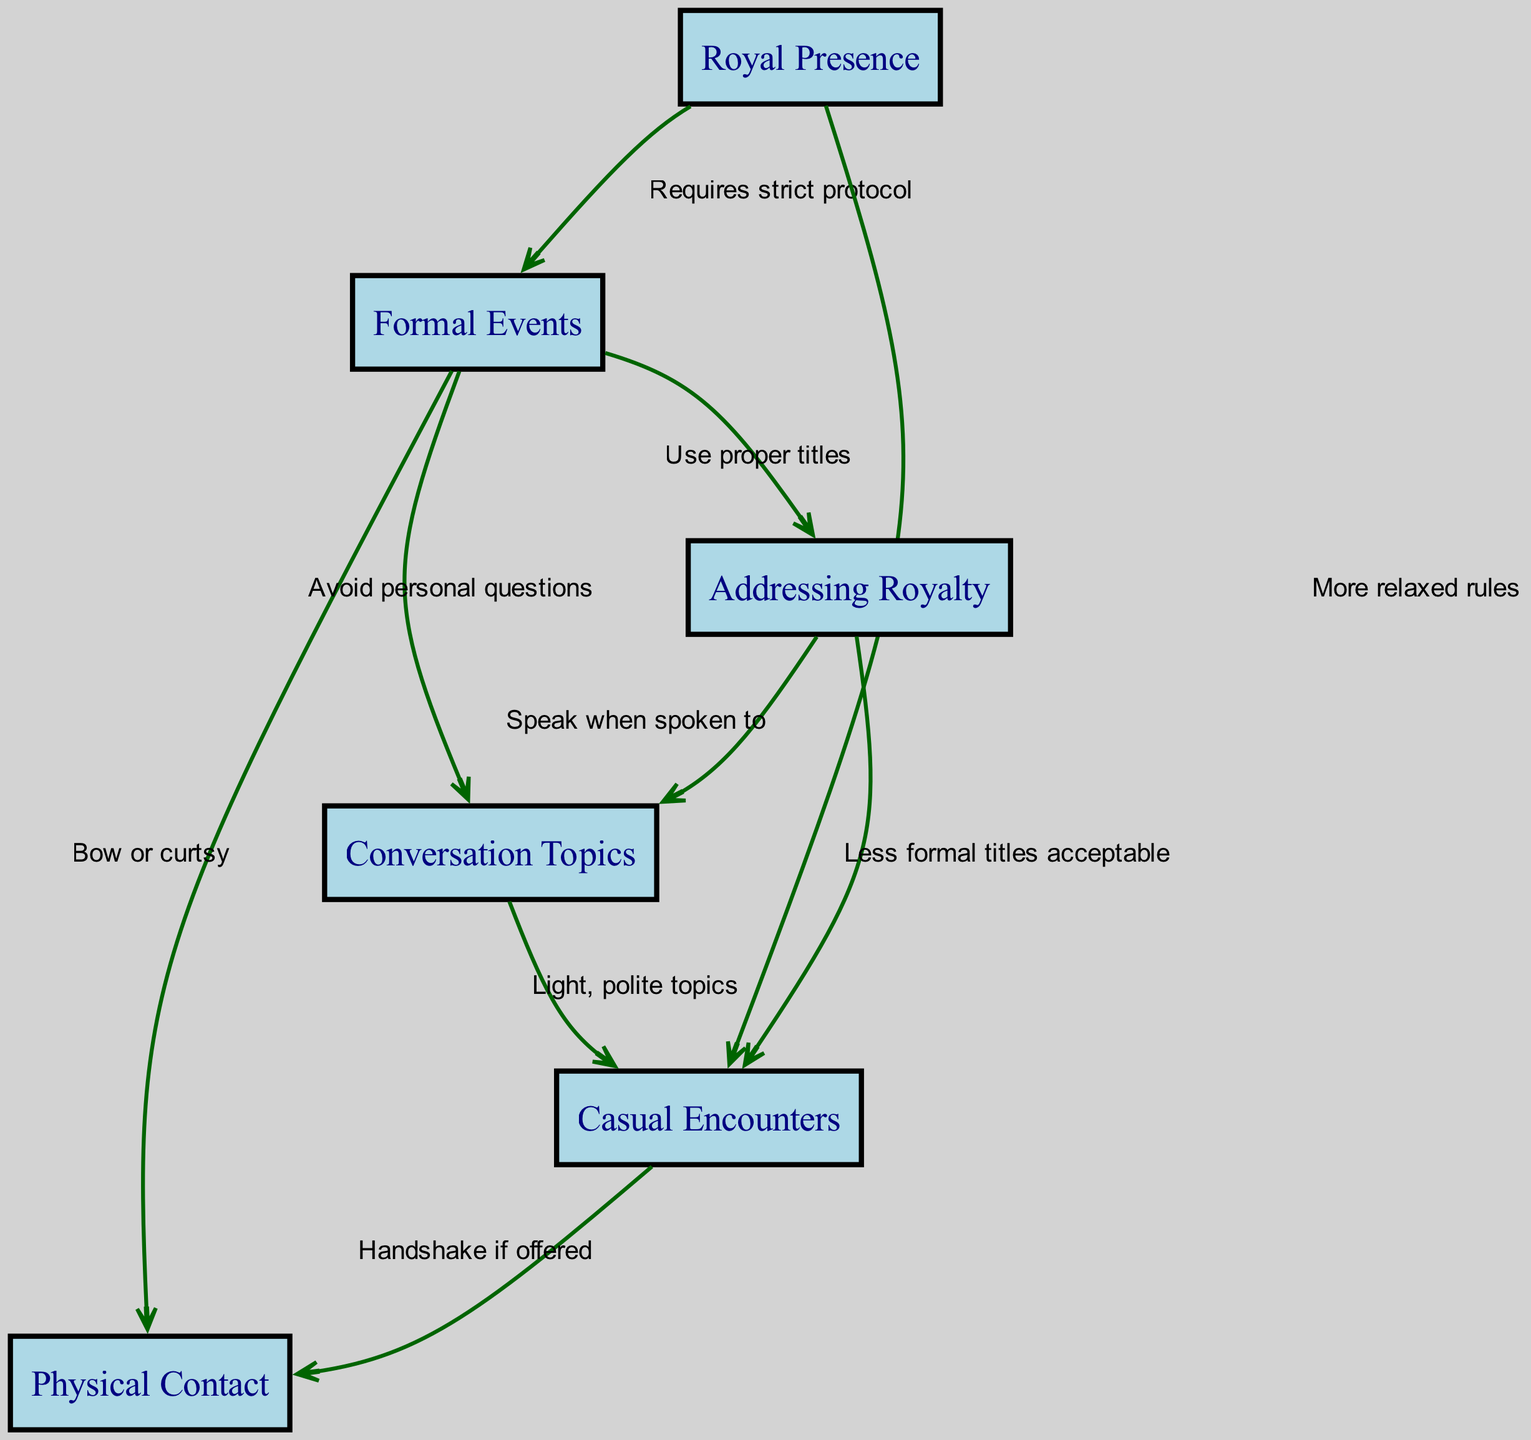What are the types of events depicted in the diagram? The diagram shows two types of events: Formal Events and Casual Encounters. These are identified as distinct nodes in the directed graph.
Answer: Formal Events, Casual Encounters How many nodes are there in the diagram? By counting the distinct nodes listed in the diagram data, we find there are a total of six nodes.
Answer: 6 What relationship exists between Formal Events and Addressing Royalty? The edge connecting Formal Events to Addressing Royalty indicates that during Formal Events, one must use proper titles when addressing royalty.
Answer: Use proper titles What is required for Royal Presence during Formal Events? The directed edge from Royal Presence to Formal Events states that Formal Events require strict protocol when interacting with royalty.
Answer: Requires strict protocol What should you discuss when speaking with royalty at Formal Events? The edge moving from Addressing Royalty to Conversation Topics shows that one should speak only when spoken to at Formal Events.
Answer: Speak when spoken to What physical gesture is expected during Casual Encounters? The edge connecting Casual Encounters to Physical Contact indicates that a handshake may occur if offered during these interactions.
Answer: Handshake if offered How do Conversation Topics differ between Formal Events and Casual Encounters? There is an edge indicating that at Formal Events one should avoid personal questions, while in Casual Encounters, light, polite topics are acceptable. This shows a difference in the nature of topics discussed.
Answer: Avoid personal questions, Light, polite topics Which node connects the rules for addressing royalty to conversation topics? The edge between Addressing Royalty and Conversation Topics implies there is a direct connection, leading to the guideline on how one should speak to royalty.
Answer: Conversation Topics What is the relationship between Casual Encounters and Physical Contact? The directed edge from Casual Encounters to Physical Contact suggests that in these settings, physical contact, like a handshake, can occur if it is offered.
Answer: Handshake if offered 